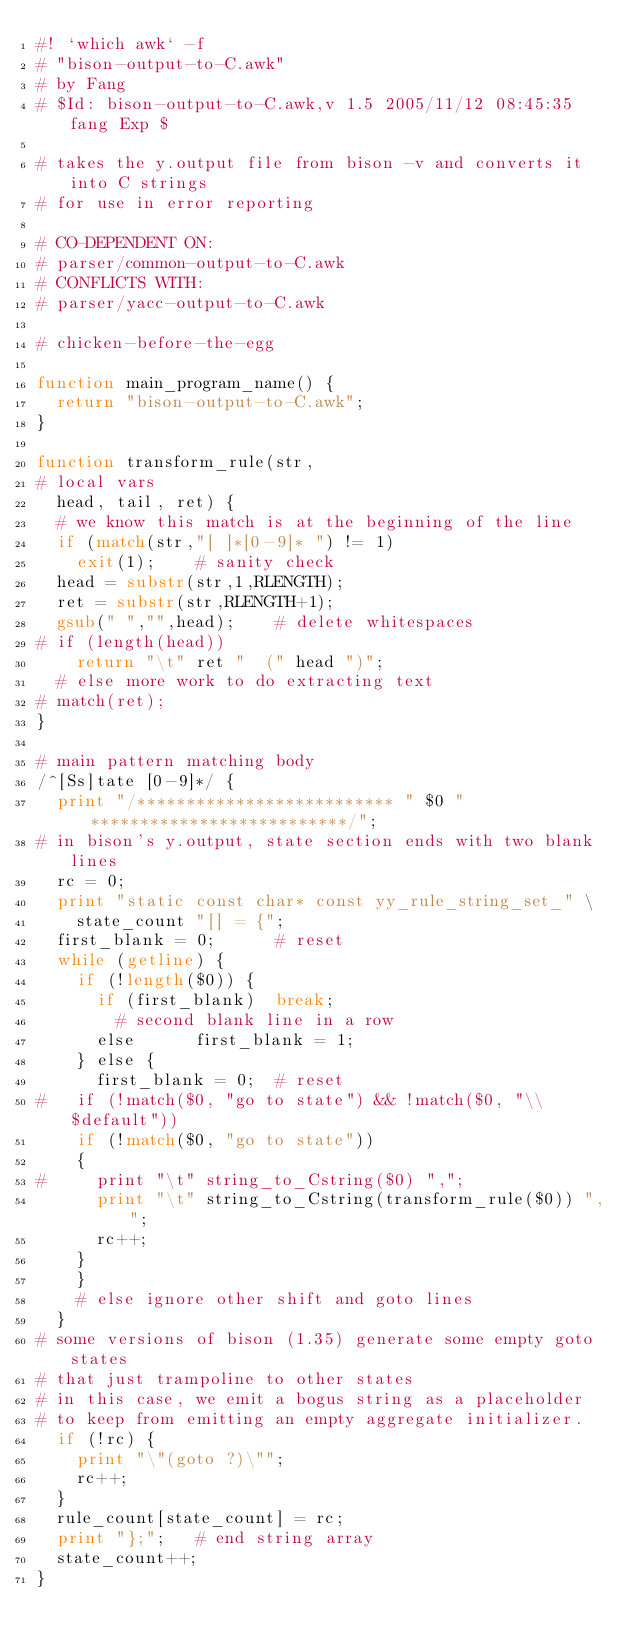<code> <loc_0><loc_0><loc_500><loc_500><_Awk_>#! `which awk` -f
# "bison-output-to-C.awk"
# by Fang
#	$Id: bison-output-to-C.awk,v 1.5 2005/11/12 08:45:35 fang Exp $

# takes the y.output file from bison -v and converts it into C strings
# for use in error reporting

# CO-DEPENDENT ON:
# parser/common-output-to-C.awk
# CONFLICTS WITH:
# parser/yacc-output-to-C.awk

# chicken-before-the-egg

function main_program_name() {
	return "bison-output-to-C.awk";
}

function transform_rule(str,
# local vars
	head, tail, ret) {
	# we know this match is at the beginning of the line
	if (match(str,"[ ]*[0-9]* ") != 1)
		exit(1);		# sanity check
	head = substr(str,1,RLENGTH);
	ret = substr(str,RLENGTH+1);
	gsub(" ","",head);		# delete whitespaces
#	if (length(head))
		return "\t" ret "  (" head ")";
	# else more work to do extracting text
#	match(ret);
}

# main pattern matching body
/^[Ss]tate [0-9]*/ {
	print "/************************** " $0 " **************************/";
# in bison's y.output, state section ends with two blank lines
	rc = 0;
	print "static const char* const yy_rule_string_set_" \
		state_count "[] = {";
	first_blank = 0;			# reset
	while (getline) {
		if (!length($0)) {
			if (first_blank)	break;
				# second blank line in a row
			else			first_blank = 1;
		} else {
			first_blank = 0;	# reset
#		if (!match($0, "go to state") && !match($0, "\\$default"))
		if (!match($0, "go to state"))
		{
#			print "\t" string_to_Cstring($0) ",";
			print "\t" string_to_Cstring(transform_rule($0)) ",";
			rc++;
		}
		}
		# else ignore other shift and goto lines
	}
# some versions of bison (1.35) generate some empty goto states
# that just trampoline to other states
# in this case, we emit a bogus string as a placeholder
# to keep from emitting an empty aggregate initializer.
	if (!rc) {
		print "\"(goto ?)\"";
		rc++;
	}
	rule_count[state_count] = rc;
	print "};";		# end string array
	state_count++;
}

</code> 